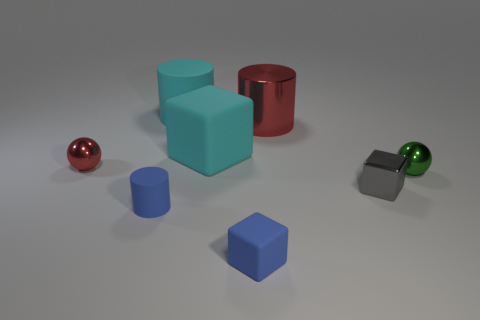Add 1 blue matte objects. How many objects exist? 9 Subtract all cylinders. How many objects are left? 5 Add 1 small balls. How many small balls are left? 3 Add 1 large cylinders. How many large cylinders exist? 3 Subtract 0 brown cylinders. How many objects are left? 8 Subtract all big green objects. Subtract all tiny red shiny balls. How many objects are left? 7 